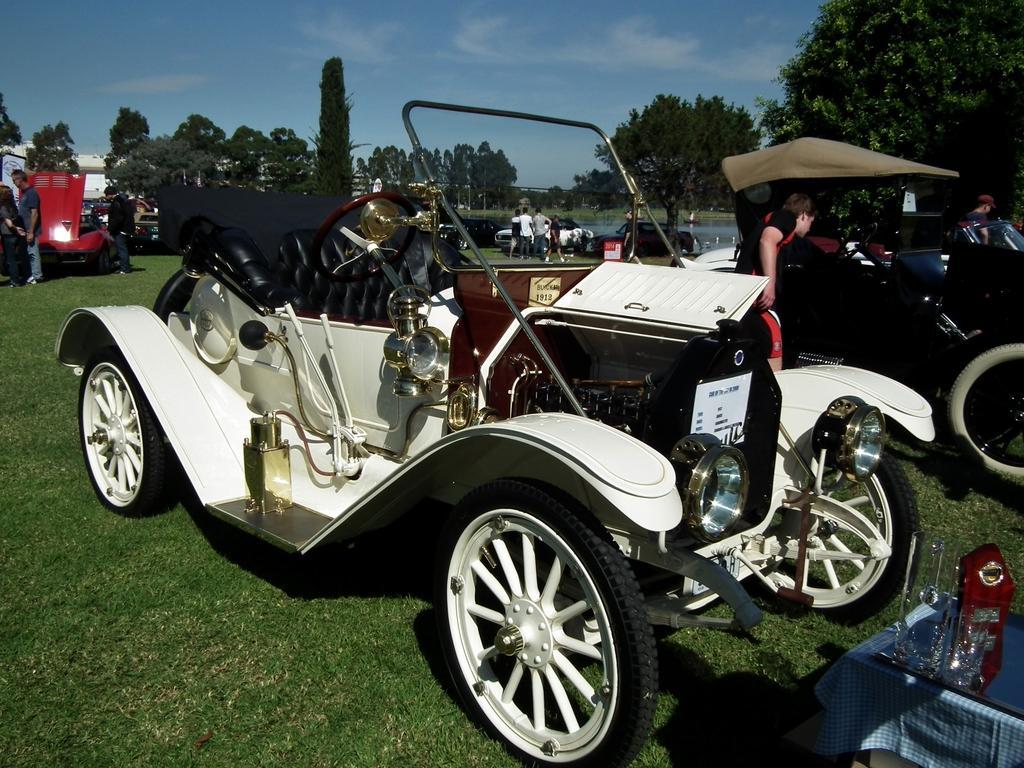Could you give a brief overview of what you see in this image? In the background we can see the sky, trees and objects. In this picture we can see people standing. We can see vehicles and green grass. In the bottom right corner of the picture we can see a platform and on a platform we can see a cloth and objects. 